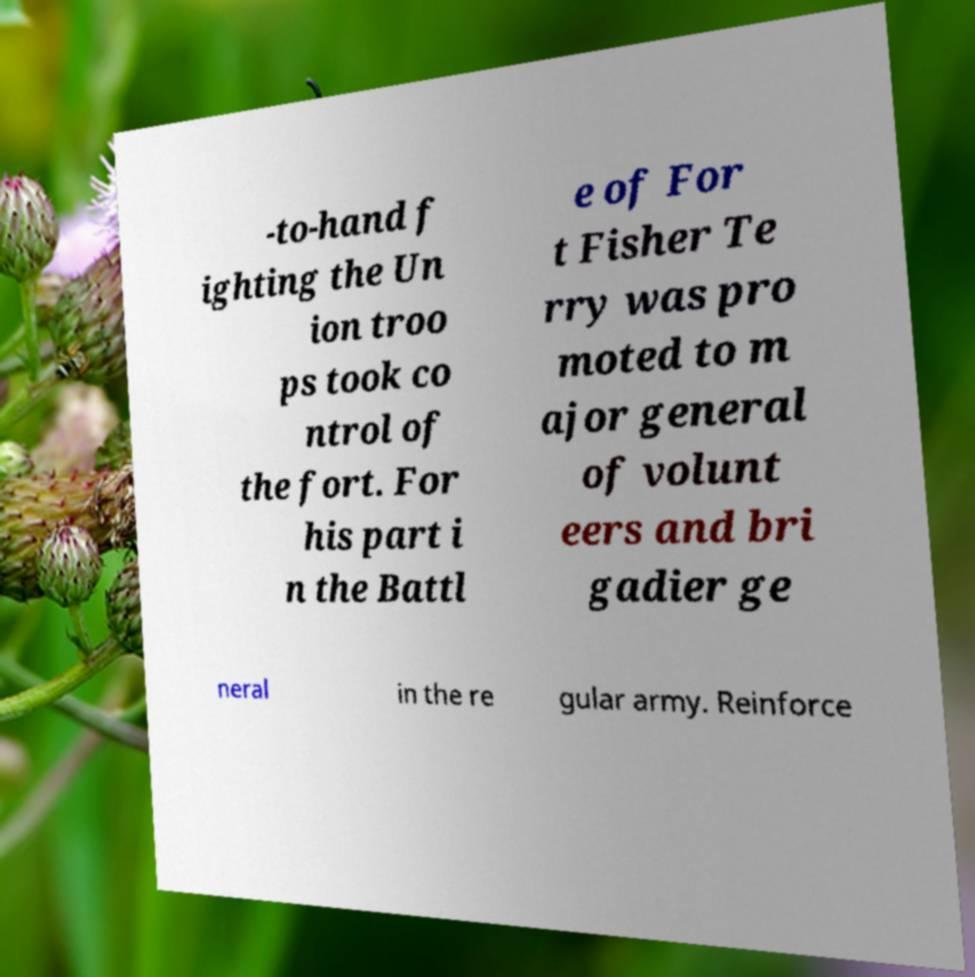For documentation purposes, I need the text within this image transcribed. Could you provide that? -to-hand f ighting the Un ion troo ps took co ntrol of the fort. For his part i n the Battl e of For t Fisher Te rry was pro moted to m ajor general of volunt eers and bri gadier ge neral in the re gular army. Reinforce 